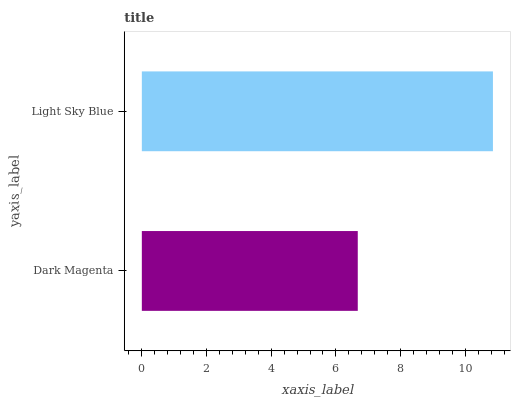Is Dark Magenta the minimum?
Answer yes or no. Yes. Is Light Sky Blue the maximum?
Answer yes or no. Yes. Is Light Sky Blue the minimum?
Answer yes or no. No. Is Light Sky Blue greater than Dark Magenta?
Answer yes or no. Yes. Is Dark Magenta less than Light Sky Blue?
Answer yes or no. Yes. Is Dark Magenta greater than Light Sky Blue?
Answer yes or no. No. Is Light Sky Blue less than Dark Magenta?
Answer yes or no. No. Is Light Sky Blue the high median?
Answer yes or no. Yes. Is Dark Magenta the low median?
Answer yes or no. Yes. Is Dark Magenta the high median?
Answer yes or no. No. Is Light Sky Blue the low median?
Answer yes or no. No. 